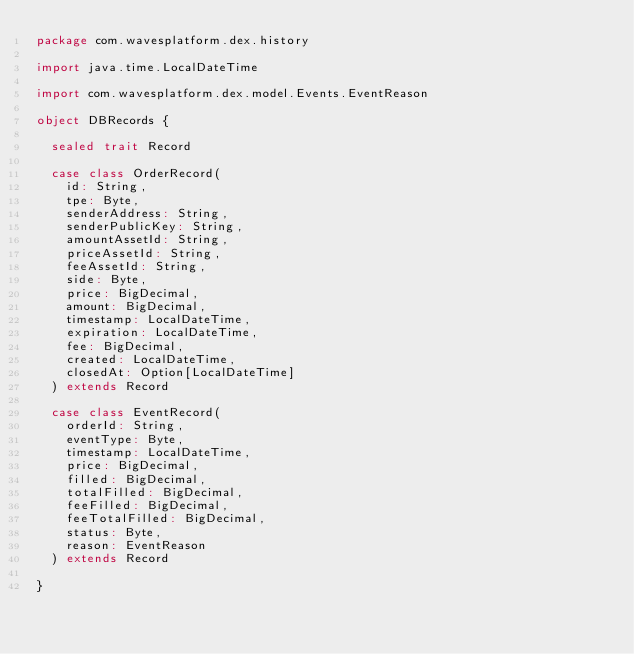Convert code to text. <code><loc_0><loc_0><loc_500><loc_500><_Scala_>package com.wavesplatform.dex.history

import java.time.LocalDateTime

import com.wavesplatform.dex.model.Events.EventReason

object DBRecords {

  sealed trait Record

  case class OrderRecord(
    id: String,
    tpe: Byte,
    senderAddress: String,
    senderPublicKey: String,
    amountAssetId: String,
    priceAssetId: String,
    feeAssetId: String,
    side: Byte,
    price: BigDecimal,
    amount: BigDecimal,
    timestamp: LocalDateTime,
    expiration: LocalDateTime,
    fee: BigDecimal,
    created: LocalDateTime,
    closedAt: Option[LocalDateTime]
  ) extends Record

  case class EventRecord(
    orderId: String,
    eventType: Byte,
    timestamp: LocalDateTime,
    price: BigDecimal,
    filled: BigDecimal,
    totalFilled: BigDecimal,
    feeFilled: BigDecimal,
    feeTotalFilled: BigDecimal,
    status: Byte,
    reason: EventReason
  ) extends Record

}
</code> 